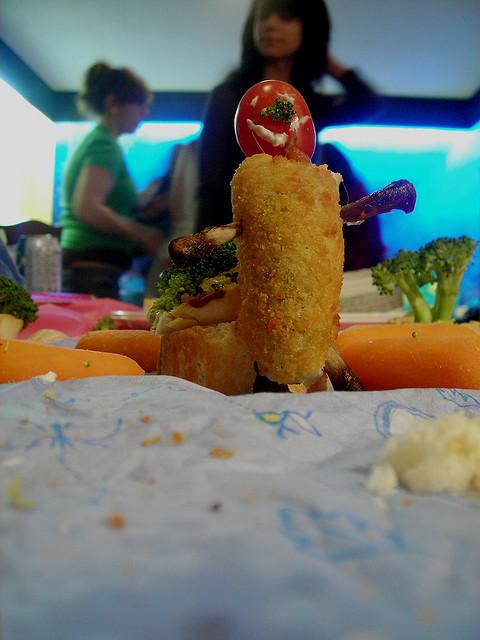Is this a banquet?
Short answer required. Yes. Where are the people in the picture?
Give a very brief answer. Background. Is this a real donut?
Answer briefly. No. How many people are in the photo?
Quick response, please. 2. 